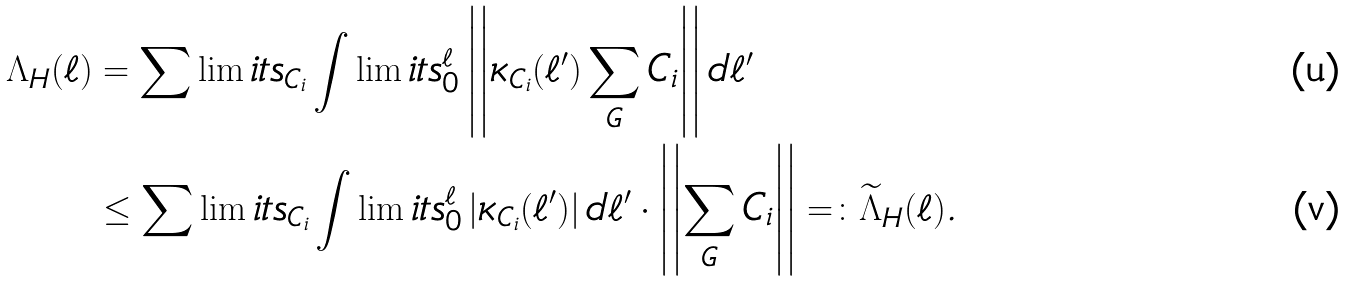<formula> <loc_0><loc_0><loc_500><loc_500>\Lambda _ { H } ( \ell ) & = \sum \lim i t s _ { C _ { i } } \int \lim i t s _ { 0 } ^ { \ell } \left | \left | \kappa _ { C _ { i } } ( \ell ^ { \prime } ) \sum _ { G } { C _ { i } } \right | \right | d \ell ^ { \prime } \\ & \leq \sum \lim i t s _ { C _ { i } } \int \lim i t s _ { 0 } ^ { \ell } \left | \kappa _ { C _ { i } } ( \ell ^ { \prime } ) \right | d \ell ^ { \prime } \cdot \left | \left | \sum _ { G } { C _ { i } } \right | \right | = \colon \widetilde { \Lambda } _ { H } ( \ell ) .</formula> 